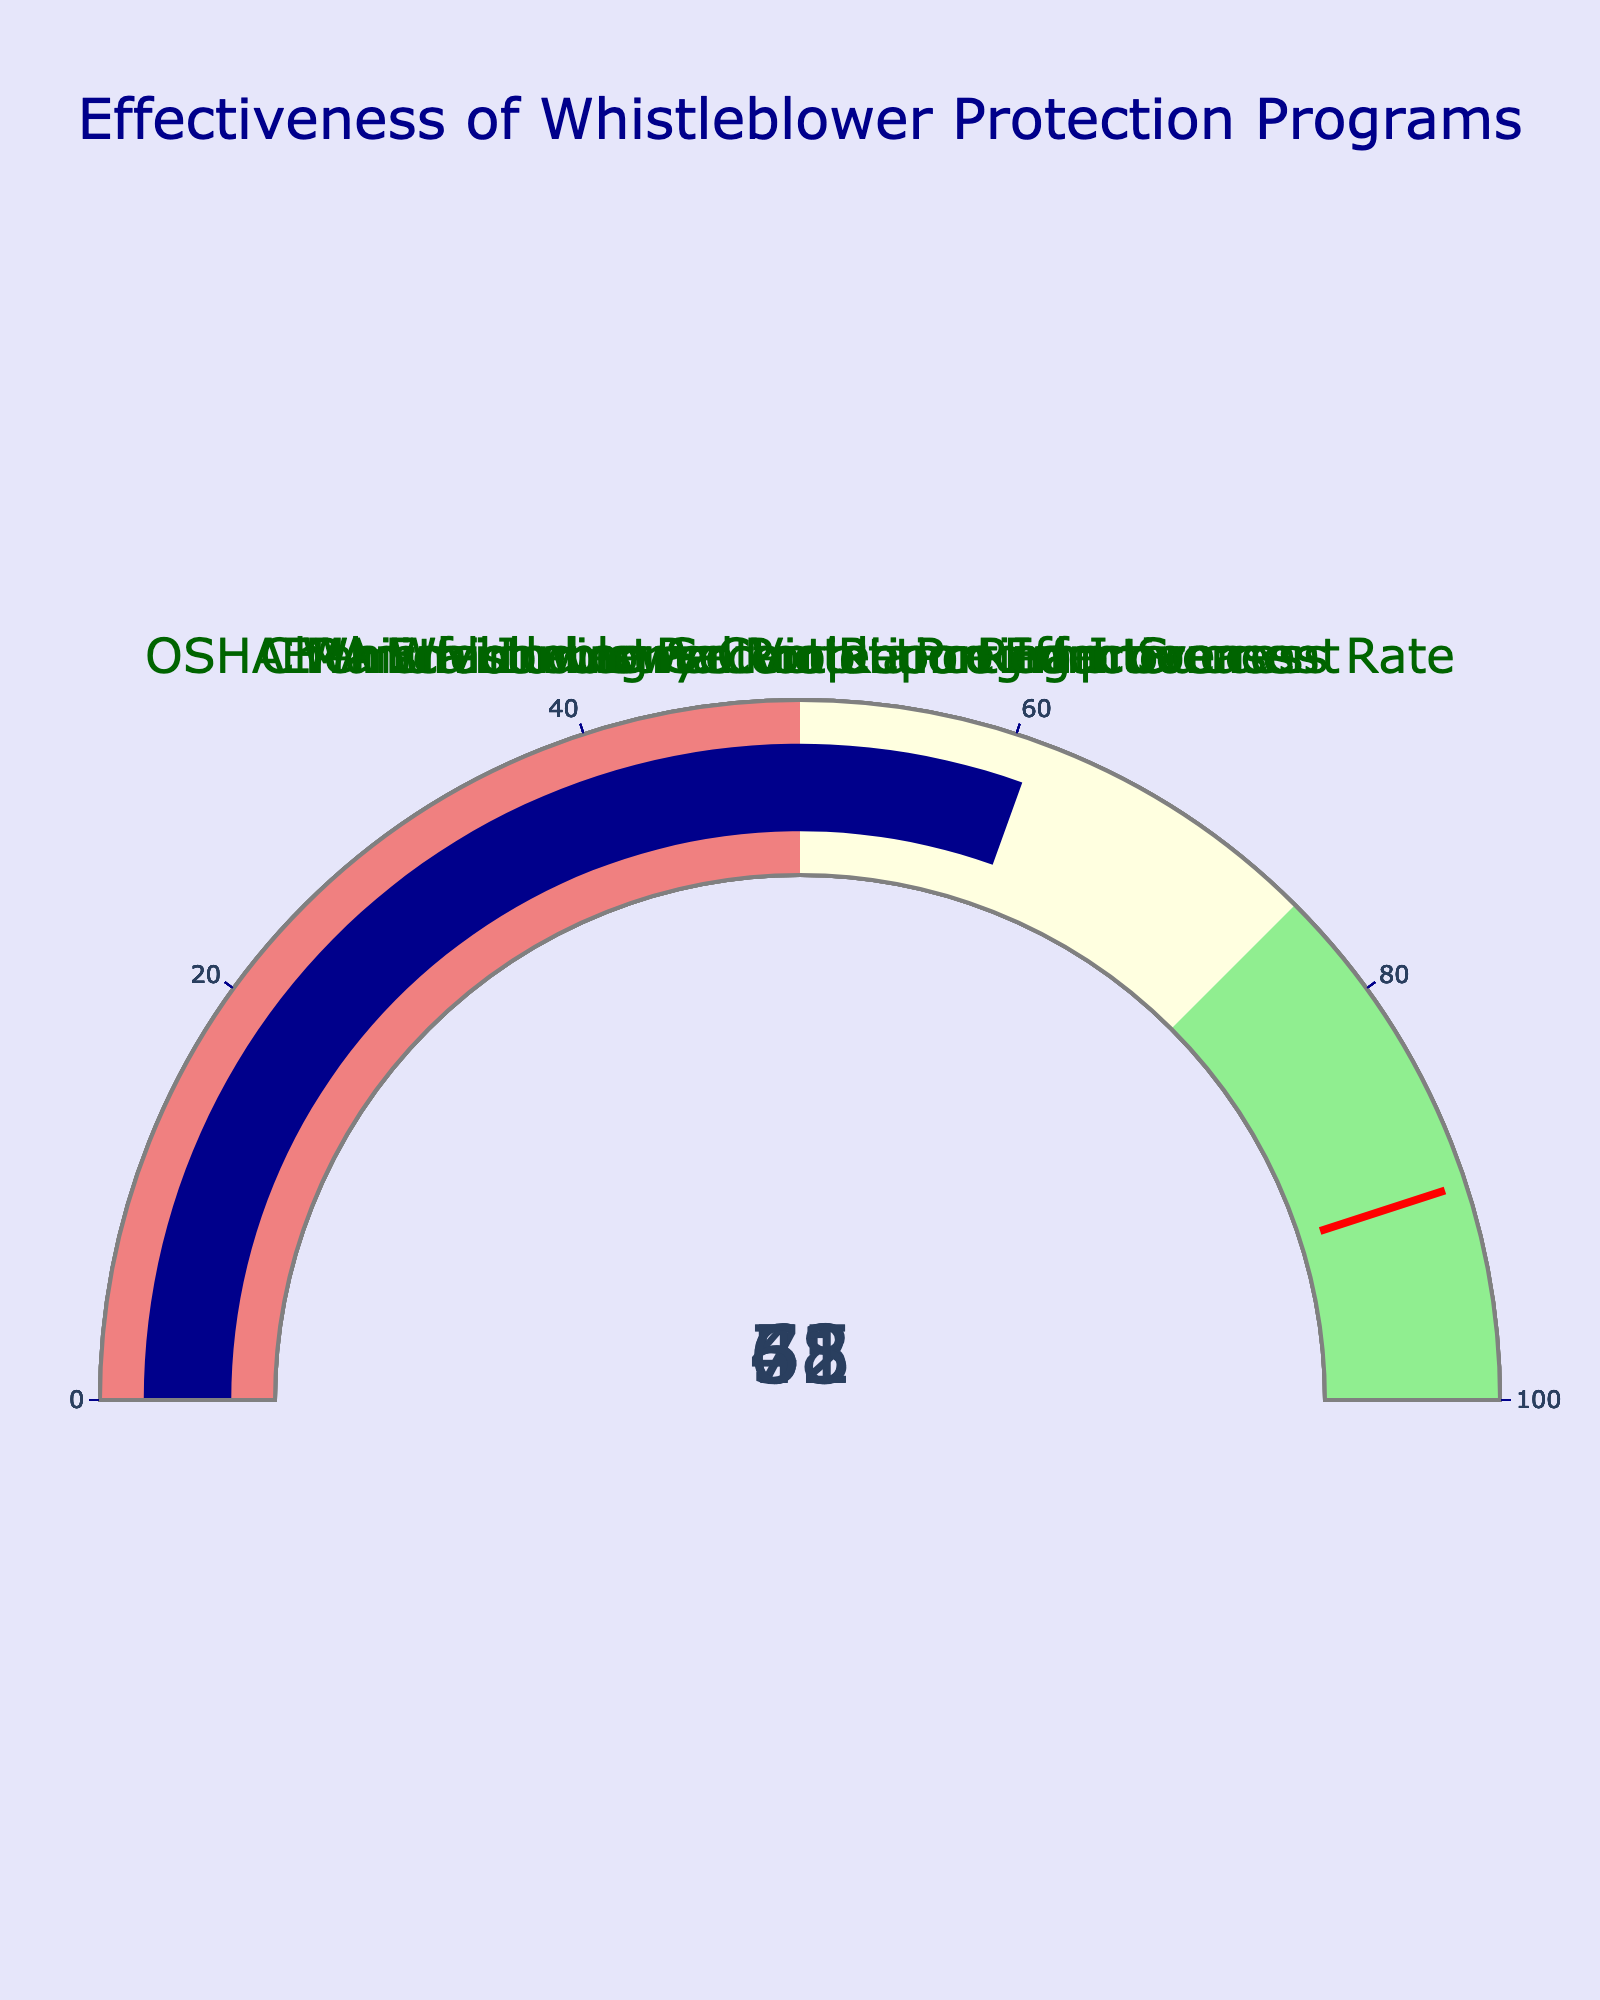what's the title of the gauge chart? The title is usually located at the top center of the figure. It summarizes the main topic.
Answer: Effectiveness of Whistleblower Protection Programs how many data points are shown in the figure? Count the number of gauges. Each gauge represents a data point.
Answer: 5 what's the value shown on the EPA Whistleblower Protection Effectiveness gauge? Locate the gauge labeled "EPA Whistleblower Protection Effectiveness" and read the value displayed.
Answer: 72 which metric has the highest effectiveness value? Compare the values on each gauge to determine which one is the highest.
Answer: EPA Whistleblower Protection Effectiveness is the Environmental Violation Reduction gauge value higher than the Manufacturing Sector Reporting Increase value? Check the values on both the Environmental Violation Reduction and Manufacturing Sector Reporting Increase gauges and compare them.
Answer: Yes what is the average value of the five data points? Add all the values from the gauges and divide by the number of data points (5). Calculation: (72 + 65 + 58 + 43 + 61) / 5 = 59.8
Answer: 59.8 how many gauges show a value greater than 60? Count the number of gauges that have values above 60.
Answer: 3 what's the difference between the highest and lowest metric values? Subtract the lowest value from the highest value. Calculation: 72 (highest) - 43 (lowest) = 29
Answer: 29 which metric shows the lowest effectiveness value? Identify the gauge with the lowest value by comparing each value.
Answer: Manufacturing Sector Reporting Increase are there any gauges whose values fall into the 'lightgreen' range (above 75)? Check if any gauges have values above 75, indicating the 'lightgreen' range.
Answer: No 